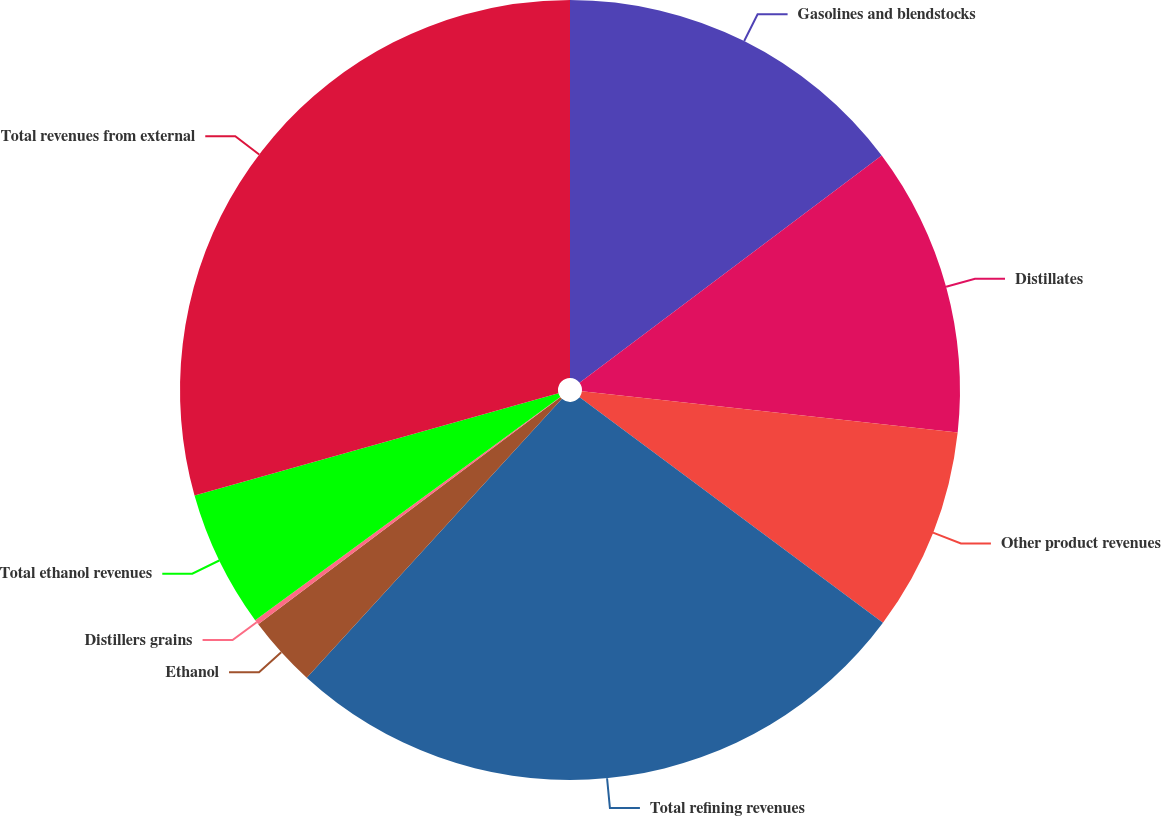<chart> <loc_0><loc_0><loc_500><loc_500><pie_chart><fcel>Gasolines and blendstocks<fcel>Distillates<fcel>Other product revenues<fcel>Total refining revenues<fcel>Ethanol<fcel>Distillers grains<fcel>Total ethanol revenues<fcel>Total revenues from external<nl><fcel>14.74%<fcel>12.0%<fcel>8.44%<fcel>26.62%<fcel>2.95%<fcel>0.21%<fcel>5.69%<fcel>29.36%<nl></chart> 